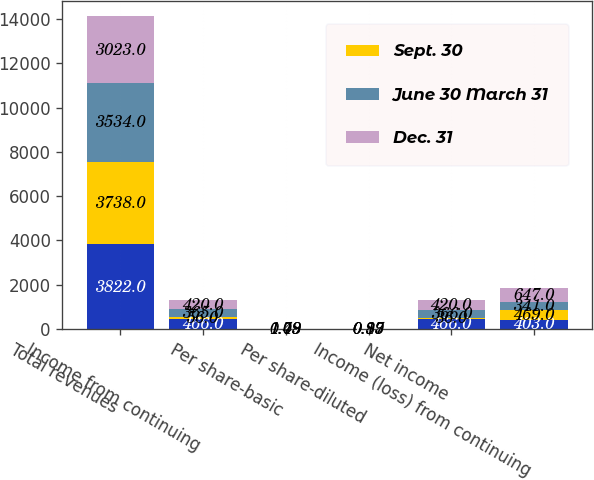Convert chart. <chart><loc_0><loc_0><loc_500><loc_500><stacked_bar_chart><ecel><fcel>Total revenues<fcel>Income from continuing<fcel>Per share-basic<fcel>Per share-diluted<fcel>Net income<fcel>Income (loss) from continuing<nl><fcel>nan<fcel>3822<fcel>466<fcel>0.94<fcel>1.12<fcel>466<fcel>403<nl><fcel>Sept. 30<fcel>3738<fcel>56<fcel>1.08<fcel>0.13<fcel>36<fcel>469<nl><fcel>June 30 March 31<fcel>3534<fcel>365<fcel>0.79<fcel>0.87<fcel>366<fcel>341<nl><fcel>Dec. 31<fcel>3023<fcel>420<fcel>1.49<fcel>0.99<fcel>420<fcel>647<nl></chart> 